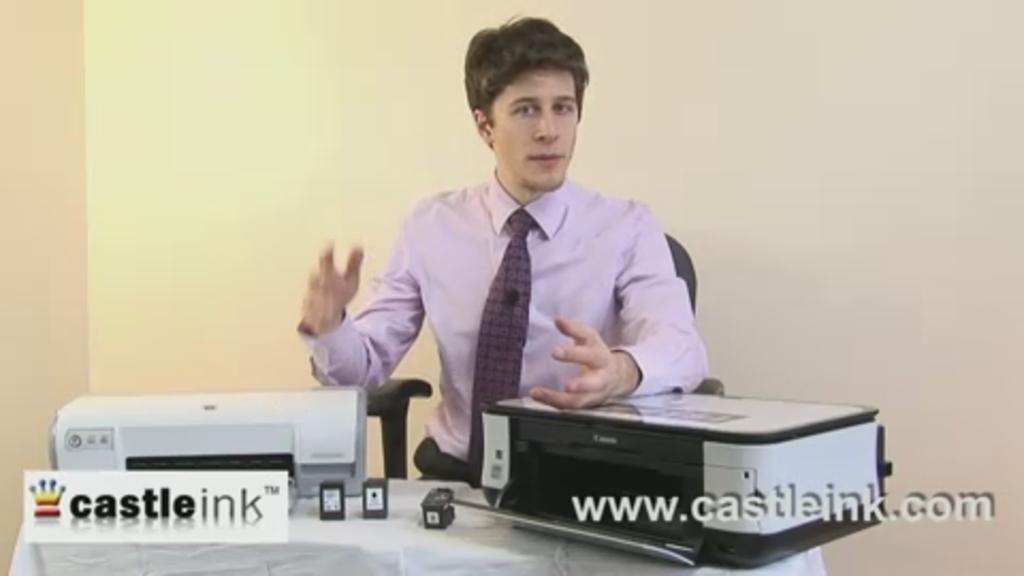What is the man in the image doing? The man is sitting in the image. What objects are in front of the man? The man has two printers in front of him. What type of crack is present in the image? There is no crack present in the image; it only features a man sitting with two printers in front of him. 